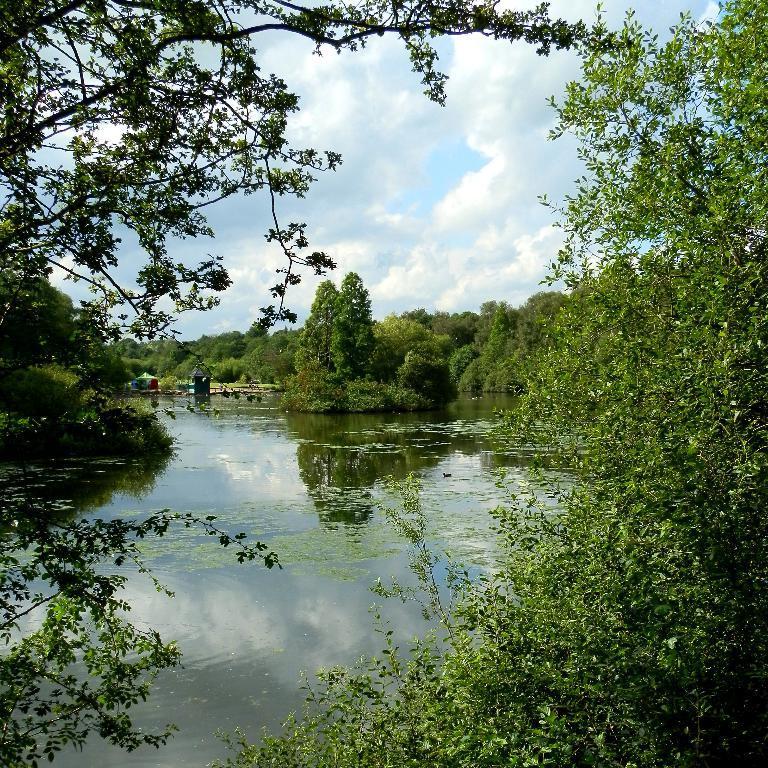In one or two sentences, can you explain what this image depicts? In this picture we can see the a lake, around we can see full of trees. 